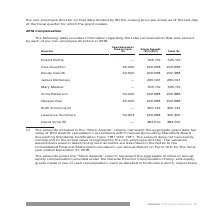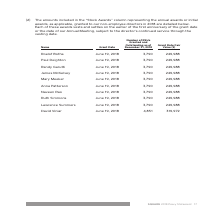According to Square's financial document, What is the total compensation earned by Roelof Botha in 2018? According to the financial document, 305,119. The relevant text states: "Roelof Botha — 305,119 305,119..." Also, What is the total compensation earned by Paul Deighton in 2018? According to the financial document, 294,998. The relevant text states: "Paul Deighton 45,000 249,998 294,998..." Also, What information does the table provide? The total compensation that was earned by each of our non-employee directors in 2018. The document states: "he following table provides information regarding the total compensation that was earned by each of our non-employee directors in 2018...." Additionally, Which director(s) earned the largest amount of total compensation? According to the financial document, David Viniar. The relevant text states: "David Viniar(5) — 382,610 382,610..." Additionally, Which director(s) earned the least amount of stock awards? The document contains multiple relevant values: Paul Deighton, Randy Garutti, Anna Patterson, Naveen Rao, Lawrence Summers. From the document: "Randy Garutti 42,500 249,998 292,488 Lawrence Summers 50,903 249,988 300,891 Naveen Rao 45,000 249,988 294,988 Anna Patterson 50,000 249,988 299,988 P..." Also, can you calculate: What is the difference in Fees Earned between Paul Deighton and Randy Garutti? Based on the calculation: 45,000-42,500, the result is 2500. This is based on the information: "Paul Deighton 45,000 249,998 294,998 Randy Garutti 42,500 249,998 292,488..." The key data points involved are: 42,500, 45,000. 